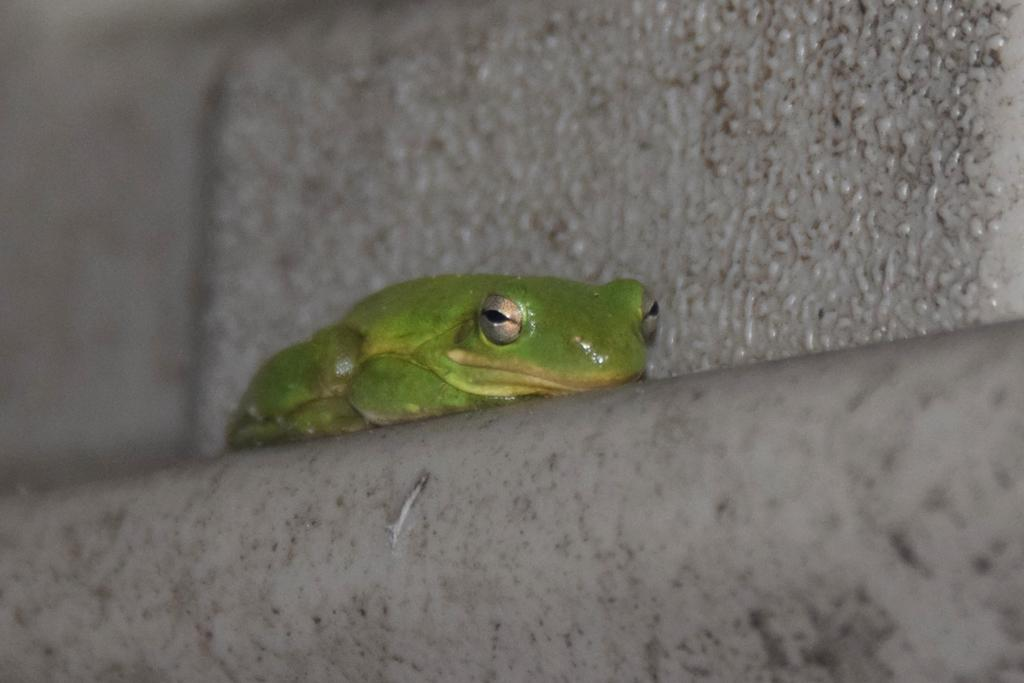What type of animal is present in the image? There is a frog in the image. What natural element is visible in the image? There is water visible in the image. What type of structure is present in the image? There is a wall in the image. What type of store can be seen in the image? There is no store present in the image. What type of army is visible in the image? There is no army present in the image. 